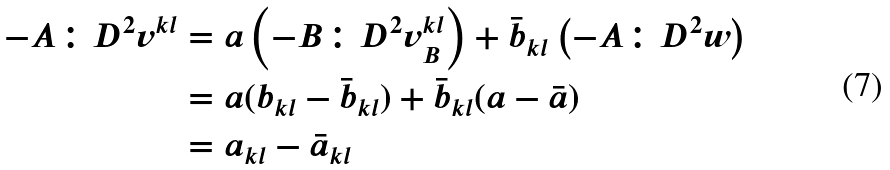<formula> <loc_0><loc_0><loc_500><loc_500>- A \colon D ^ { 2 } v ^ { k l } & = a \left ( - B \colon D ^ { 2 } v ^ { k l } _ { B } \right ) + \bar { b } _ { k l } \left ( - A \colon D ^ { 2 } w \right ) \\ & = a ( b _ { k l } - \bar { b } _ { k l } ) + \bar { b } _ { k l } ( a - \bar { a } ) \\ & = a _ { k l } - \bar { a } _ { k l }</formula> 